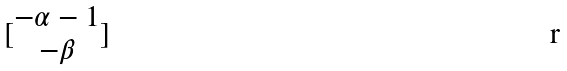Convert formula to latex. <formula><loc_0><loc_0><loc_500><loc_500>[ \begin{matrix} - \alpha - 1 \\ - \beta \end{matrix} ]</formula> 